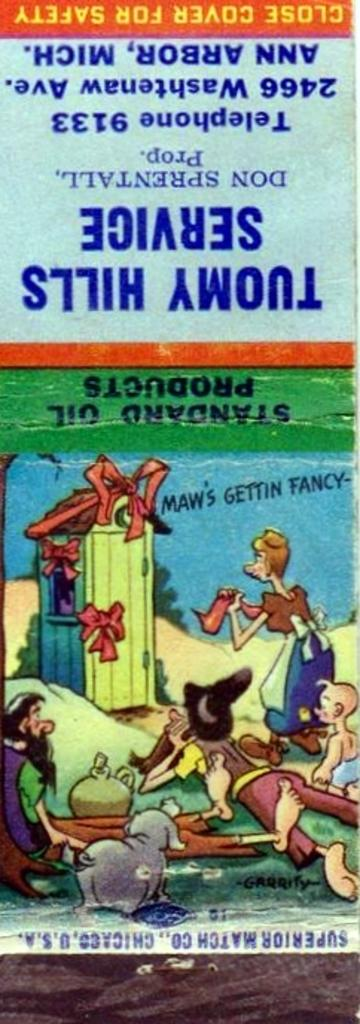What is featured in the picture? There is a poster in the picture. What type of images are on the poster? The poster contains animated pictures. Is there any text on the poster? Yes, there is text at the top of the poster. Is there an umbrella shown in the animated pictures on the poster? There is no mention of an umbrella in the provided facts, so we cannot determine if it is present in the animated pictures on the poster. 